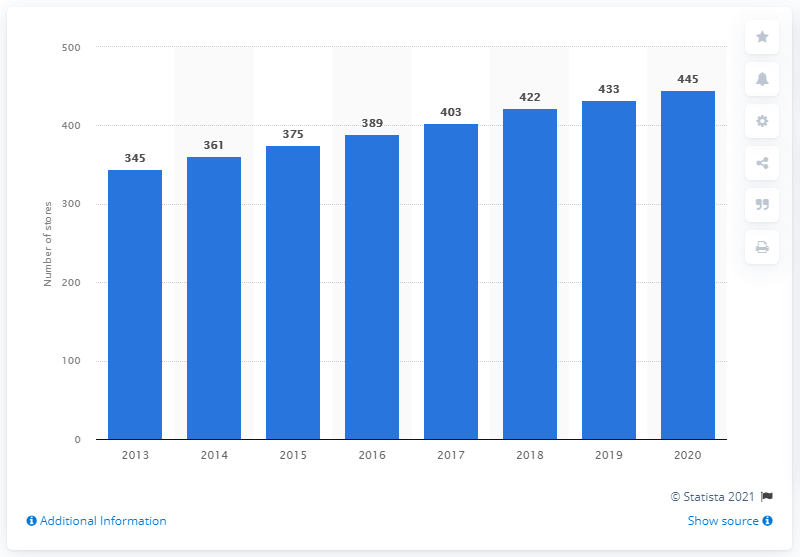Point out several critical features in this image. As of the end of August 2020, there were 445 IKEA stores worldwide. In 2013, IKEA operated 345 stores worldwide. 